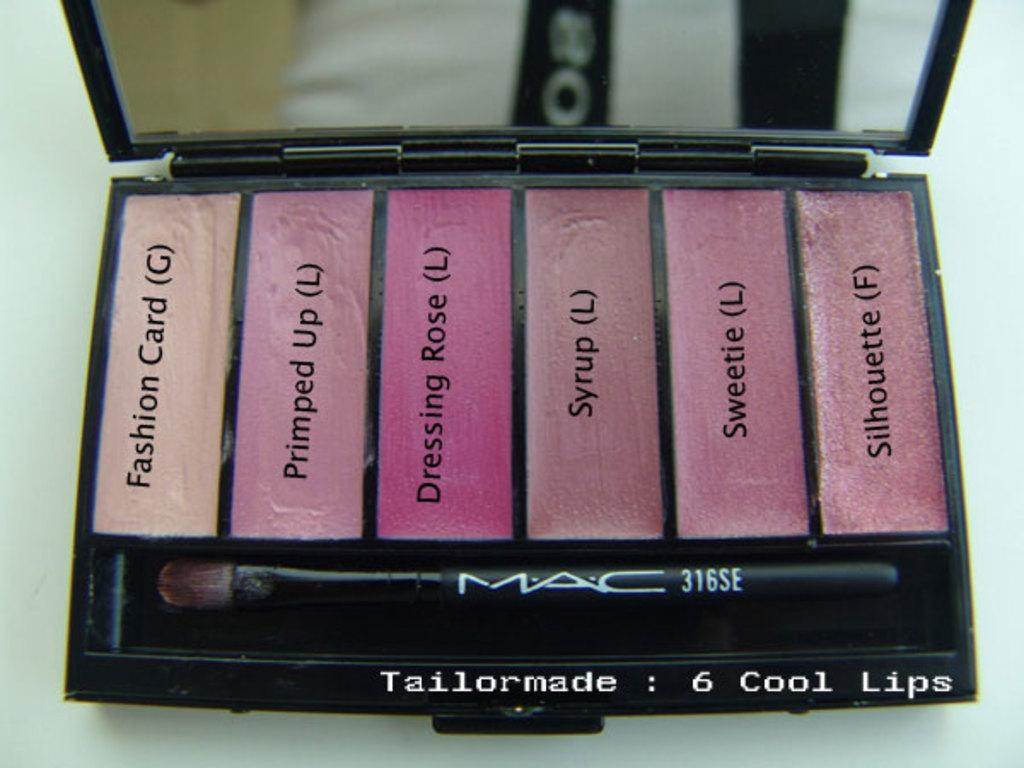Provide a one-sentence caption for the provided image. A makeup kit with the text 6 cool lips printed at the bottom. 